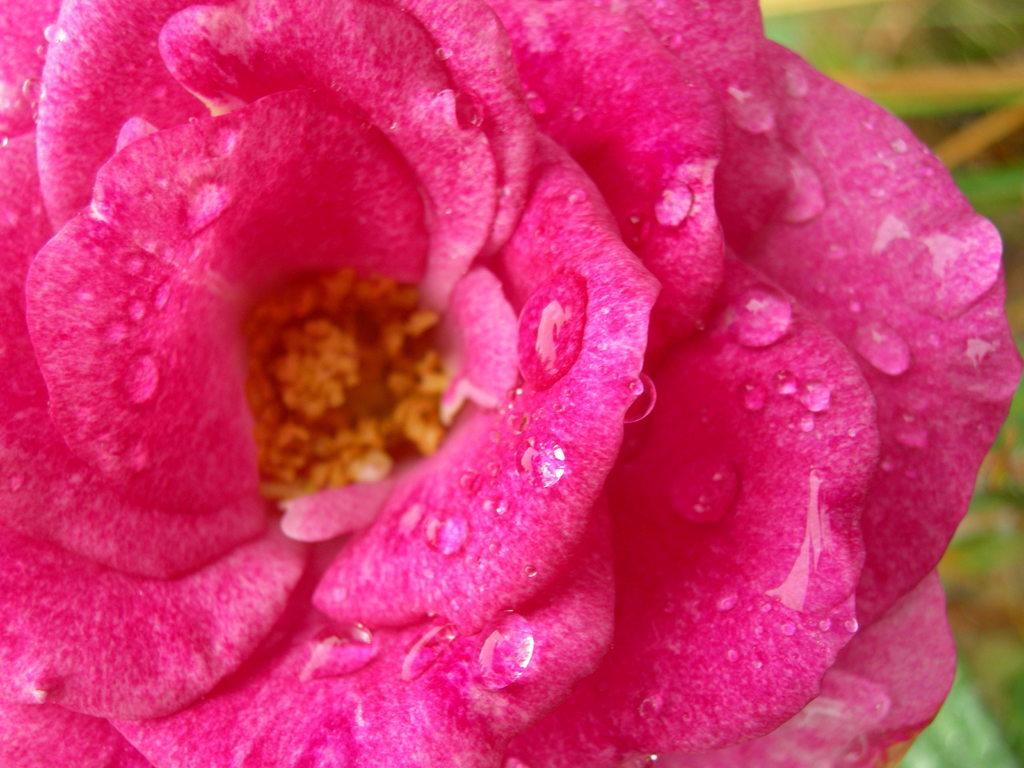What is the condition of the rose in the image? The rose has water droplets on it. What color is the rose in the image? The rose is pink in color. What type of operation is being performed on the rose in the image? There is no operation being performed on the rose in the image; it is simply a rose with water droplets on it. 